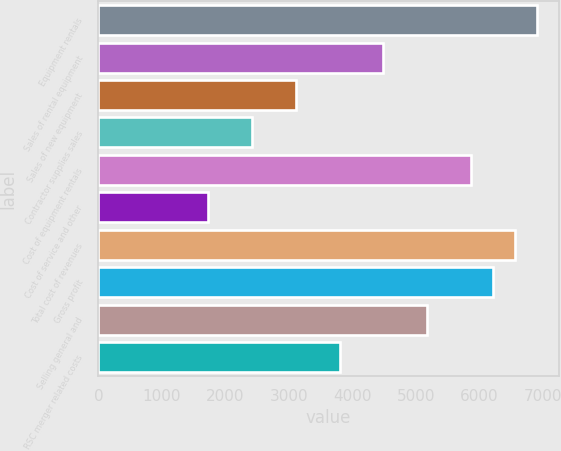<chart> <loc_0><loc_0><loc_500><loc_500><bar_chart><fcel>Equipment rentals<fcel>Sales of rental equipment<fcel>Sales of new equipment<fcel>Contractor supplies sales<fcel>Cost of equipment rentals<fcel>Cost of service and other<fcel>Total cost of revenues<fcel>Gross profit<fcel>Selling general and<fcel>RSC merger related costs<nl><fcel>6909.19<fcel>4491.25<fcel>3109.57<fcel>2418.73<fcel>5872.93<fcel>1727.89<fcel>6563.77<fcel>6218.35<fcel>5182.09<fcel>3800.41<nl></chart> 